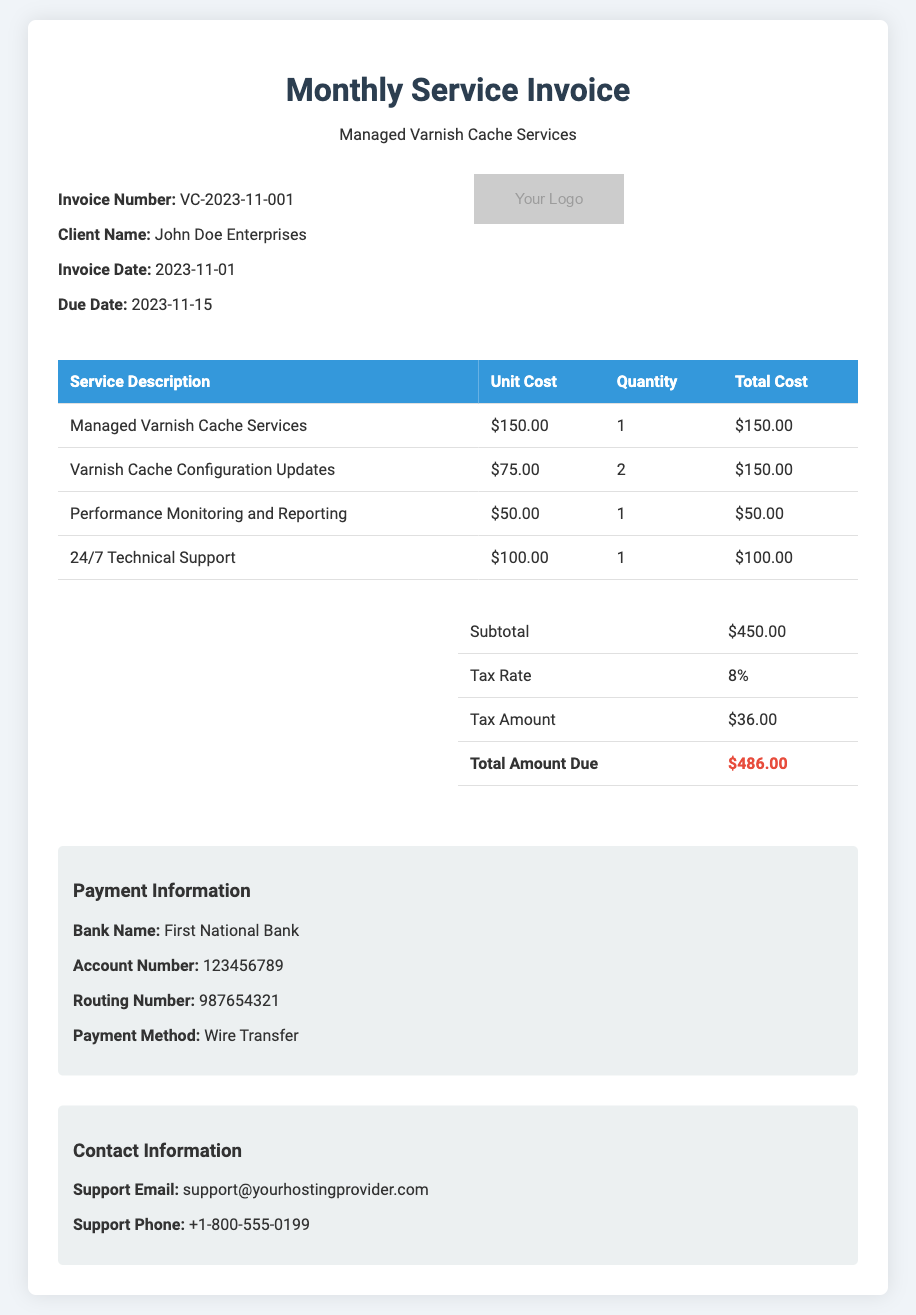What is the invoice number? The invoice number is specified in the document to uniquely identify the invoice, which is VC-2023-11-001.
Answer: VC-2023-11-001 Who is the client? The client name is provided in the document, indicating the recipient of the invoice, which is John Doe Enterprises.
Answer: John Doe Enterprises What is the total amount due? The document summarizes the total amount due at the end, which includes subtotal and tax, resulting in $486.00.
Answer: $486.00 What is the tax amount? The tax amount is detailed separately in the summary table, showing the calculated tax as $36.00.
Answer: $36.00 How many configuration updates were made? The document lists the quantity of configuration updates under service descriptions, which is 2.
Answer: 2 What is the payment method? The document specifies the method of payment as Wire Transfer under the payment information section.
Answer: Wire Transfer What is the due date? The document provides the due date for payment, which is stated as 2023-11-15.
Answer: 2023-11-15 Which service has a unit cost of $100.00? The unit cost of $100.00 is associated with the service description of 24/7 Technical Support.
Answer: 24/7 Technical Support What bank is mentioned for payments? The bank information is referenced in the payment section, which lists First National Bank.
Answer: First National Bank 